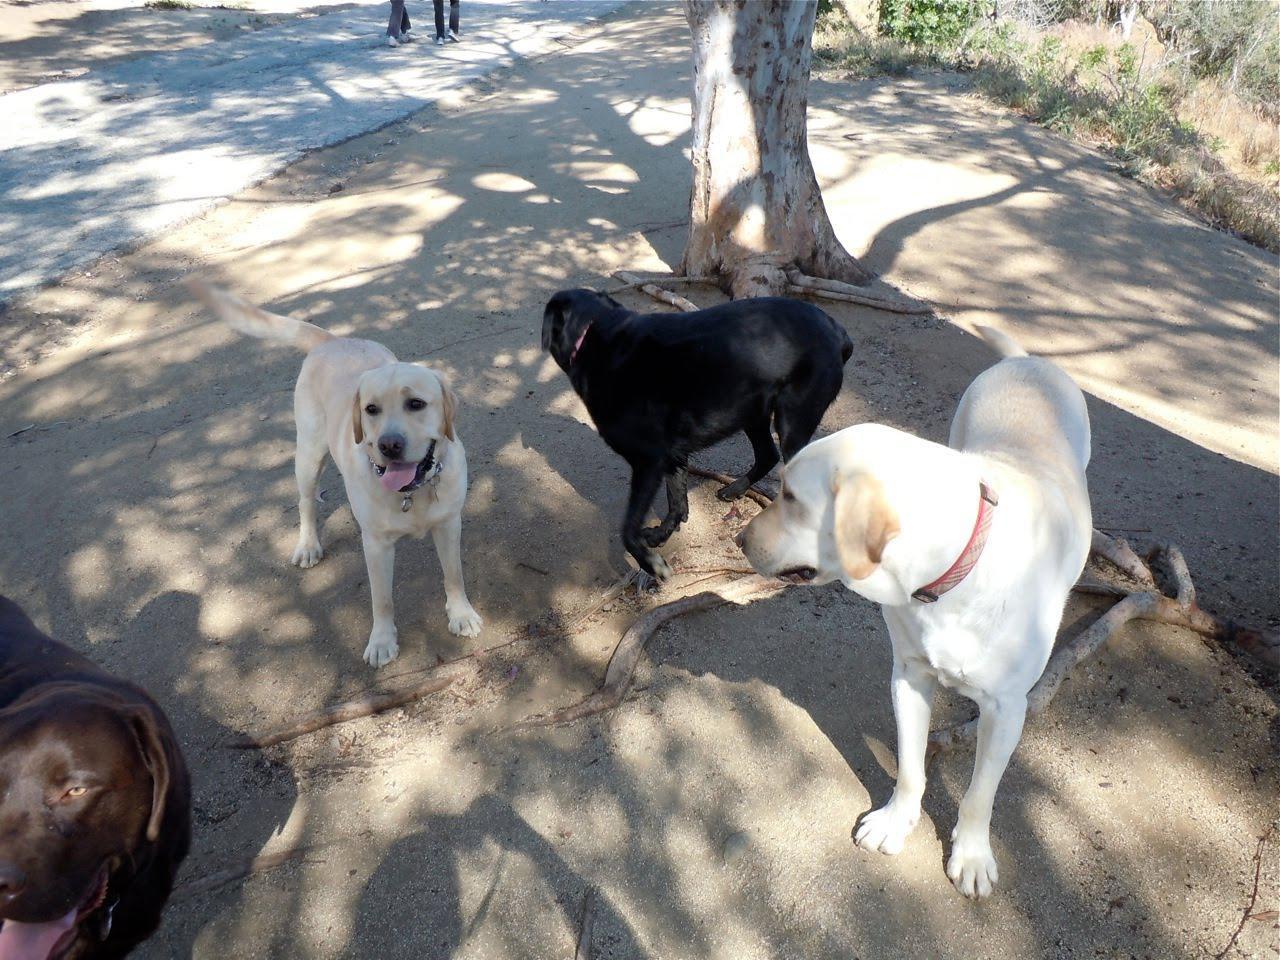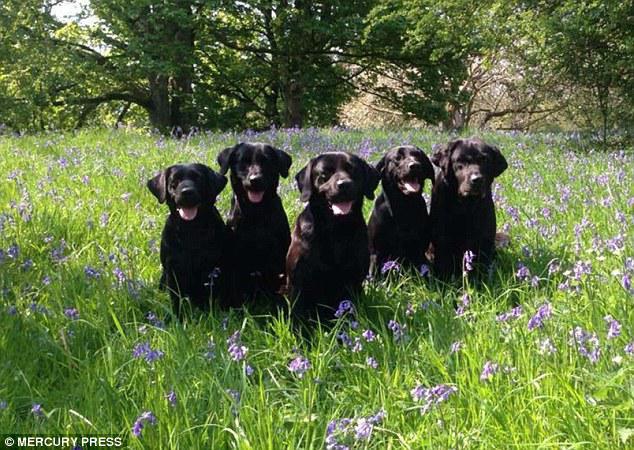The first image is the image on the left, the second image is the image on the right. Considering the images on both sides, is "One of the images includes dogs on the grass." valid? Answer yes or no. Yes. The first image is the image on the left, the second image is the image on the right. Given the left and right images, does the statement "The image on the right shows a group of dogs that are all sitting or lying down, and all but one of the dogs are showing their tongues." hold true? Answer yes or no. Yes. 